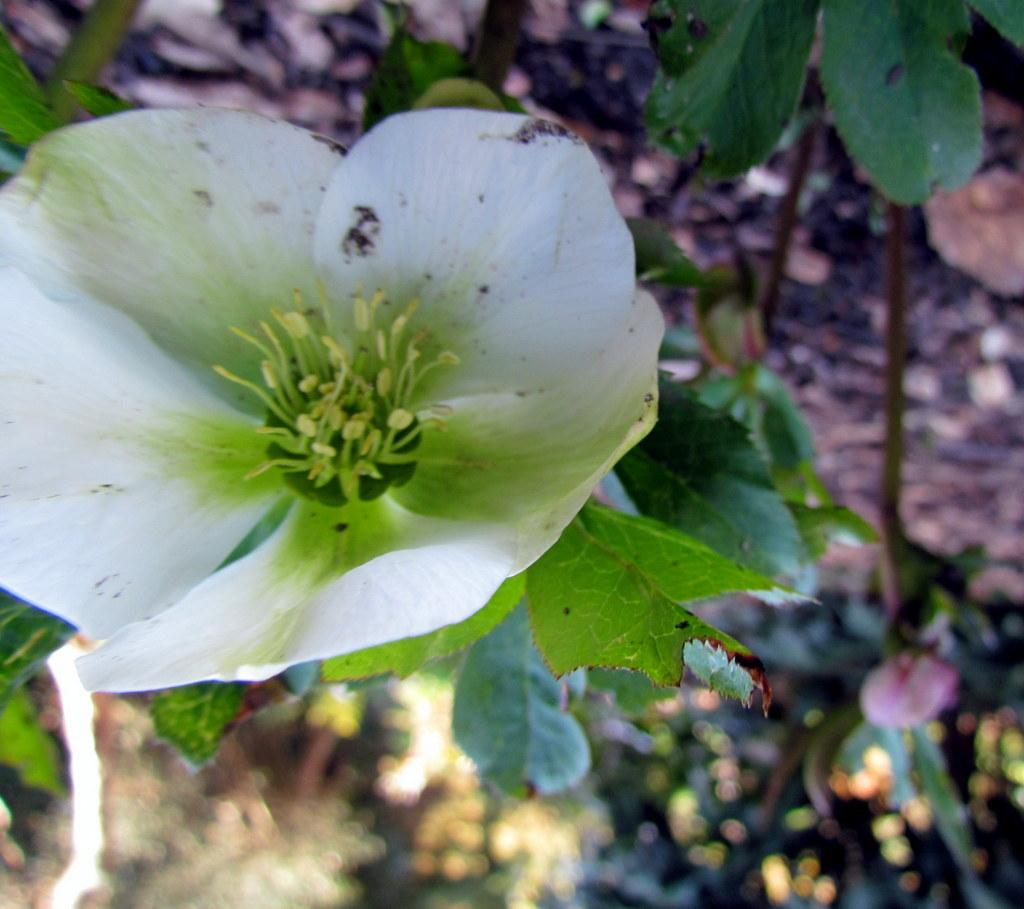What is the main subject of the image? There is a flower in the image. What else can be seen in the image besides the flower? There are leaves in the image. Can you describe the background of the image? The background of the image is blurred. What type of snake can be seen slithering through the leaves in the image? There is no snake present in the image; it only features a flower and leaves. Can you tell me where the zipper is located on the flower in the image? There is no zipper present on the flower in the image. 